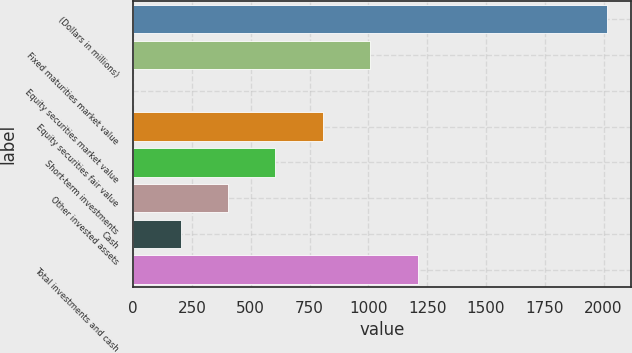Convert chart. <chart><loc_0><loc_0><loc_500><loc_500><bar_chart><fcel>(Dollars in millions)<fcel>Fixed maturities market value<fcel>Equity securities market value<fcel>Equity securities fair value<fcel>Short-term investments<fcel>Other invested assets<fcel>Cash<fcel>Total investments and cash<nl><fcel>2015<fcel>1007.85<fcel>0.7<fcel>806.42<fcel>604.99<fcel>403.56<fcel>202.13<fcel>1209.28<nl></chart> 